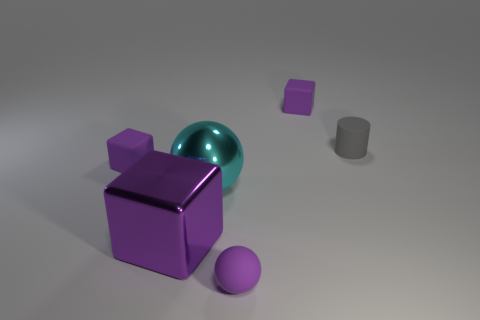There is a metal thing that is right of the large purple thing; is its color the same as the small matte cylinder?
Keep it short and to the point. No. How many rubber things are either balls or gray cylinders?
Provide a succinct answer. 2. What is the shape of the large purple shiny thing?
Your response must be concise. Cube. Is there anything else that is the same material as the gray cylinder?
Your answer should be compact. Yes. Does the large cyan ball have the same material as the large purple object?
Your answer should be very brief. Yes. There is a big metallic cube in front of the tiny purple block to the left of the big purple block; is there a large purple metal block on the left side of it?
Offer a very short reply. No. What number of other things are the same shape as the big cyan shiny thing?
Provide a succinct answer. 1. There is a purple object that is both to the left of the purple matte sphere and behind the large purple thing; what shape is it?
Your response must be concise. Cube. What is the color of the matte block that is behind the gray rubber thing that is right of the matte block that is behind the small gray object?
Ensure brevity in your answer.  Purple. Is the number of purple matte cubes on the right side of the tiny purple ball greater than the number of purple shiny cubes that are behind the gray cylinder?
Your answer should be very brief. Yes. 